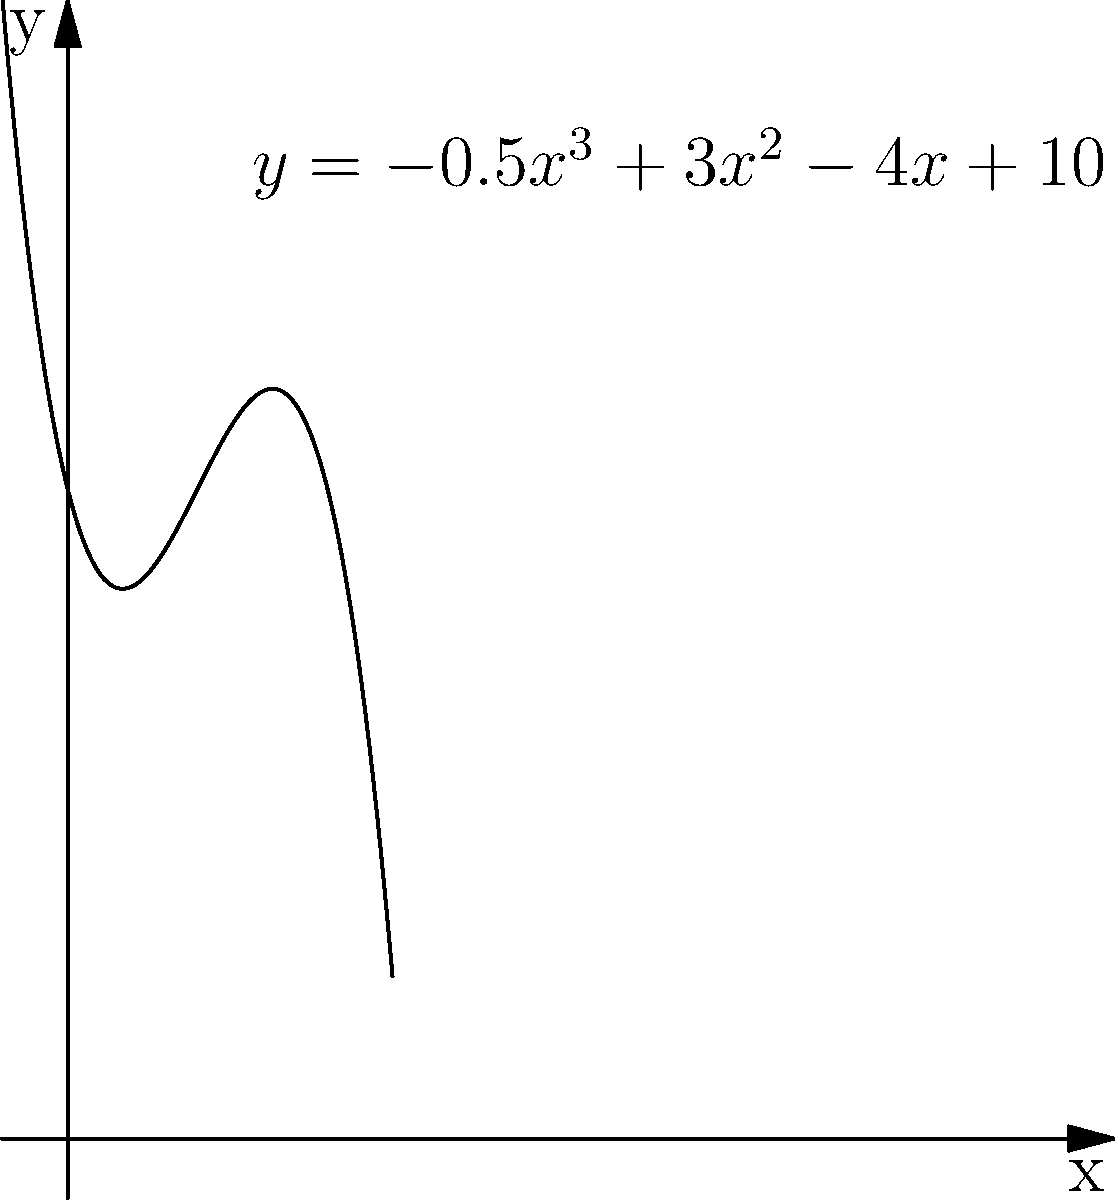As an environmental engineer, you're analyzing the land use efficiency of different solar panel array configurations. The polynomial function $y = -0.5x^3 + 3x^2 - 4x + 10$ represents the relationship between the number of rows (x) in a solar panel array and the land use efficiency (y) in kWh/m². At what number of rows does the land use efficiency reach its maximum value? To find the maximum value of the land use efficiency, we need to follow these steps:

1) The maximum point occurs where the derivative of the function is zero. Let's find the derivative:

   $f'(x) = -1.5x^2 + 6x - 4$

2) Set the derivative equal to zero and solve for x:

   $-1.5x^2 + 6x - 4 = 0$

3) This is a quadratic equation. We can solve it using the quadratic formula:
   $x = \frac{-b \pm \sqrt{b^2 - 4ac}}{2a}$

   Where $a = -1.5$, $b = 6$, and $c = -4$

4) Plugging these values into the quadratic formula:

   $x = \frac{-6 \pm \sqrt{36 - 4(-1.5)(-4)}}{2(-1.5)}$
   $= \frac{-6 \pm \sqrt{36 - 24}}{-3}$
   $= \frac{-6 \pm \sqrt{12}}{-3}$
   $= \frac{-6 \pm 2\sqrt{3}}{-3}$

5) This gives us two solutions:

   $x_1 = \frac{-6 + 2\sqrt{3}}{-3} = 2 - \frac{2\sqrt{3}}{3}$
   $x_2 = \frac{-6 - 2\sqrt{3}}{-3} = 2 + \frac{2\sqrt{3}}{3}$

6) Since we're looking for a maximum (not a minimum), and the leading coefficient of our original function is negative (indicating the parabola opens downward), we choose the smaller value:

   $x = 2 - \frac{2\sqrt{3}}{3}$

7) This is approximately equal to 0.845 rows. However, since we can't have a fractional number of rows, we need to round to the nearest whole number.

Therefore, the land use efficiency reaches its maximum value when there are 1 row of solar panels.
Answer: 1 row 